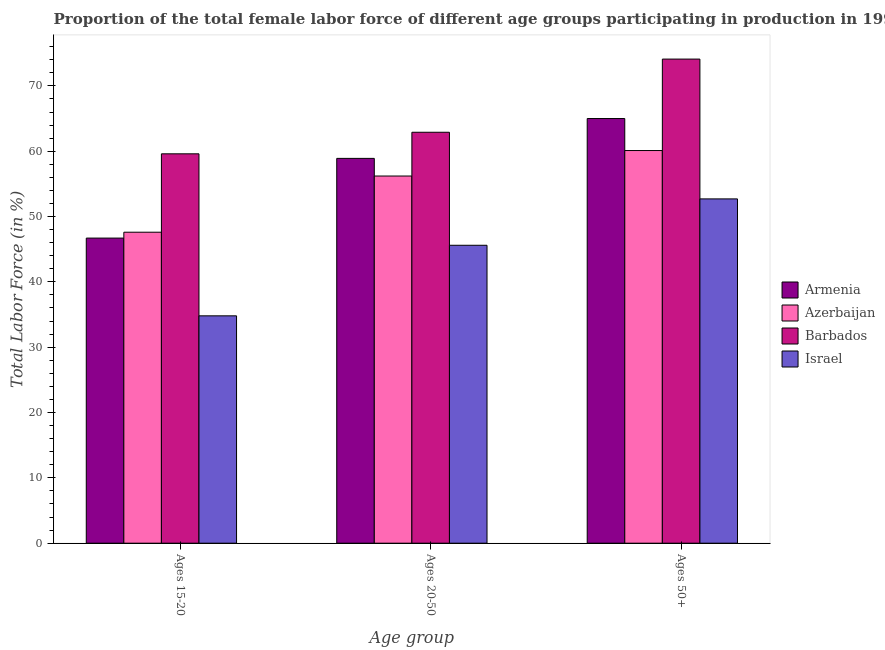Are the number of bars per tick equal to the number of legend labels?
Keep it short and to the point. Yes. Are the number of bars on each tick of the X-axis equal?
Ensure brevity in your answer.  Yes. How many bars are there on the 1st tick from the right?
Give a very brief answer. 4. What is the label of the 1st group of bars from the left?
Offer a very short reply. Ages 15-20. What is the percentage of female labor force within the age group 20-50 in Israel?
Keep it short and to the point. 45.6. Across all countries, what is the maximum percentage of female labor force within the age group 20-50?
Ensure brevity in your answer.  62.9. Across all countries, what is the minimum percentage of female labor force within the age group 20-50?
Offer a very short reply. 45.6. In which country was the percentage of female labor force within the age group 20-50 maximum?
Provide a succinct answer. Barbados. What is the total percentage of female labor force within the age group 15-20 in the graph?
Keep it short and to the point. 188.7. What is the difference between the percentage of female labor force within the age group 15-20 in Barbados and that in Israel?
Give a very brief answer. 24.8. What is the difference between the percentage of female labor force above age 50 in Armenia and the percentage of female labor force within the age group 15-20 in Israel?
Keep it short and to the point. 30.2. What is the average percentage of female labor force above age 50 per country?
Give a very brief answer. 62.97. What is the difference between the percentage of female labor force within the age group 20-50 and percentage of female labor force above age 50 in Azerbaijan?
Your answer should be compact. -3.9. In how many countries, is the percentage of female labor force above age 50 greater than 64 %?
Offer a terse response. 2. What is the ratio of the percentage of female labor force above age 50 in Azerbaijan to that in Armenia?
Your answer should be very brief. 0.92. Is the percentage of female labor force within the age group 20-50 in Azerbaijan less than that in Israel?
Offer a terse response. No. What is the difference between the highest and the lowest percentage of female labor force within the age group 20-50?
Your answer should be compact. 17.3. Is the sum of the percentage of female labor force within the age group 20-50 in Israel and Azerbaijan greater than the maximum percentage of female labor force within the age group 15-20 across all countries?
Offer a terse response. Yes. What does the 3rd bar from the right in Ages 50+ represents?
Offer a terse response. Azerbaijan. How many bars are there?
Offer a very short reply. 12. How many countries are there in the graph?
Offer a very short reply. 4. What is the difference between two consecutive major ticks on the Y-axis?
Your answer should be very brief. 10. Are the values on the major ticks of Y-axis written in scientific E-notation?
Keep it short and to the point. No. Does the graph contain any zero values?
Offer a terse response. No. Does the graph contain grids?
Keep it short and to the point. No. How many legend labels are there?
Keep it short and to the point. 4. How are the legend labels stacked?
Give a very brief answer. Vertical. What is the title of the graph?
Your response must be concise. Proportion of the total female labor force of different age groups participating in production in 1995. What is the label or title of the X-axis?
Your answer should be compact. Age group. What is the Total Labor Force (in %) of Armenia in Ages 15-20?
Give a very brief answer. 46.7. What is the Total Labor Force (in %) in Azerbaijan in Ages 15-20?
Offer a terse response. 47.6. What is the Total Labor Force (in %) of Barbados in Ages 15-20?
Keep it short and to the point. 59.6. What is the Total Labor Force (in %) of Israel in Ages 15-20?
Your answer should be very brief. 34.8. What is the Total Labor Force (in %) in Armenia in Ages 20-50?
Keep it short and to the point. 58.9. What is the Total Labor Force (in %) in Azerbaijan in Ages 20-50?
Provide a succinct answer. 56.2. What is the Total Labor Force (in %) in Barbados in Ages 20-50?
Offer a terse response. 62.9. What is the Total Labor Force (in %) in Israel in Ages 20-50?
Ensure brevity in your answer.  45.6. What is the Total Labor Force (in %) of Azerbaijan in Ages 50+?
Your answer should be very brief. 60.1. What is the Total Labor Force (in %) of Barbados in Ages 50+?
Make the answer very short. 74.1. What is the Total Labor Force (in %) of Israel in Ages 50+?
Provide a succinct answer. 52.7. Across all Age group, what is the maximum Total Labor Force (in %) of Armenia?
Offer a very short reply. 65. Across all Age group, what is the maximum Total Labor Force (in %) of Azerbaijan?
Provide a short and direct response. 60.1. Across all Age group, what is the maximum Total Labor Force (in %) of Barbados?
Your answer should be compact. 74.1. Across all Age group, what is the maximum Total Labor Force (in %) of Israel?
Your answer should be compact. 52.7. Across all Age group, what is the minimum Total Labor Force (in %) of Armenia?
Keep it short and to the point. 46.7. Across all Age group, what is the minimum Total Labor Force (in %) of Azerbaijan?
Your answer should be very brief. 47.6. Across all Age group, what is the minimum Total Labor Force (in %) in Barbados?
Provide a short and direct response. 59.6. Across all Age group, what is the minimum Total Labor Force (in %) in Israel?
Offer a very short reply. 34.8. What is the total Total Labor Force (in %) of Armenia in the graph?
Your response must be concise. 170.6. What is the total Total Labor Force (in %) of Azerbaijan in the graph?
Provide a succinct answer. 163.9. What is the total Total Labor Force (in %) of Barbados in the graph?
Offer a terse response. 196.6. What is the total Total Labor Force (in %) in Israel in the graph?
Provide a short and direct response. 133.1. What is the difference between the Total Labor Force (in %) in Armenia in Ages 15-20 and that in Ages 20-50?
Your answer should be compact. -12.2. What is the difference between the Total Labor Force (in %) of Azerbaijan in Ages 15-20 and that in Ages 20-50?
Give a very brief answer. -8.6. What is the difference between the Total Labor Force (in %) of Barbados in Ages 15-20 and that in Ages 20-50?
Your answer should be compact. -3.3. What is the difference between the Total Labor Force (in %) in Israel in Ages 15-20 and that in Ages 20-50?
Provide a succinct answer. -10.8. What is the difference between the Total Labor Force (in %) in Armenia in Ages 15-20 and that in Ages 50+?
Give a very brief answer. -18.3. What is the difference between the Total Labor Force (in %) of Barbados in Ages 15-20 and that in Ages 50+?
Ensure brevity in your answer.  -14.5. What is the difference between the Total Labor Force (in %) of Israel in Ages 15-20 and that in Ages 50+?
Make the answer very short. -17.9. What is the difference between the Total Labor Force (in %) of Armenia in Ages 20-50 and that in Ages 50+?
Make the answer very short. -6.1. What is the difference between the Total Labor Force (in %) of Israel in Ages 20-50 and that in Ages 50+?
Provide a succinct answer. -7.1. What is the difference between the Total Labor Force (in %) in Armenia in Ages 15-20 and the Total Labor Force (in %) in Azerbaijan in Ages 20-50?
Provide a succinct answer. -9.5. What is the difference between the Total Labor Force (in %) of Armenia in Ages 15-20 and the Total Labor Force (in %) of Barbados in Ages 20-50?
Make the answer very short. -16.2. What is the difference between the Total Labor Force (in %) in Azerbaijan in Ages 15-20 and the Total Labor Force (in %) in Barbados in Ages 20-50?
Keep it short and to the point. -15.3. What is the difference between the Total Labor Force (in %) in Barbados in Ages 15-20 and the Total Labor Force (in %) in Israel in Ages 20-50?
Provide a succinct answer. 14. What is the difference between the Total Labor Force (in %) in Armenia in Ages 15-20 and the Total Labor Force (in %) in Azerbaijan in Ages 50+?
Give a very brief answer. -13.4. What is the difference between the Total Labor Force (in %) of Armenia in Ages 15-20 and the Total Labor Force (in %) of Barbados in Ages 50+?
Give a very brief answer. -27.4. What is the difference between the Total Labor Force (in %) of Azerbaijan in Ages 15-20 and the Total Labor Force (in %) of Barbados in Ages 50+?
Keep it short and to the point. -26.5. What is the difference between the Total Labor Force (in %) of Azerbaijan in Ages 15-20 and the Total Labor Force (in %) of Israel in Ages 50+?
Your answer should be very brief. -5.1. What is the difference between the Total Labor Force (in %) in Armenia in Ages 20-50 and the Total Labor Force (in %) in Barbados in Ages 50+?
Make the answer very short. -15.2. What is the difference between the Total Labor Force (in %) in Armenia in Ages 20-50 and the Total Labor Force (in %) in Israel in Ages 50+?
Your response must be concise. 6.2. What is the difference between the Total Labor Force (in %) of Azerbaijan in Ages 20-50 and the Total Labor Force (in %) of Barbados in Ages 50+?
Give a very brief answer. -17.9. What is the difference between the Total Labor Force (in %) of Azerbaijan in Ages 20-50 and the Total Labor Force (in %) of Israel in Ages 50+?
Provide a short and direct response. 3.5. What is the average Total Labor Force (in %) of Armenia per Age group?
Provide a succinct answer. 56.87. What is the average Total Labor Force (in %) in Azerbaijan per Age group?
Your response must be concise. 54.63. What is the average Total Labor Force (in %) of Barbados per Age group?
Offer a very short reply. 65.53. What is the average Total Labor Force (in %) of Israel per Age group?
Offer a terse response. 44.37. What is the difference between the Total Labor Force (in %) of Armenia and Total Labor Force (in %) of Azerbaijan in Ages 15-20?
Keep it short and to the point. -0.9. What is the difference between the Total Labor Force (in %) of Armenia and Total Labor Force (in %) of Barbados in Ages 15-20?
Your response must be concise. -12.9. What is the difference between the Total Labor Force (in %) in Azerbaijan and Total Labor Force (in %) in Barbados in Ages 15-20?
Your answer should be compact. -12. What is the difference between the Total Labor Force (in %) in Azerbaijan and Total Labor Force (in %) in Israel in Ages 15-20?
Provide a succinct answer. 12.8. What is the difference between the Total Labor Force (in %) in Barbados and Total Labor Force (in %) in Israel in Ages 15-20?
Ensure brevity in your answer.  24.8. What is the difference between the Total Labor Force (in %) of Armenia and Total Labor Force (in %) of Azerbaijan in Ages 20-50?
Provide a succinct answer. 2.7. What is the difference between the Total Labor Force (in %) of Armenia and Total Labor Force (in %) of Barbados in Ages 20-50?
Provide a short and direct response. -4. What is the difference between the Total Labor Force (in %) of Azerbaijan and Total Labor Force (in %) of Barbados in Ages 20-50?
Your answer should be compact. -6.7. What is the difference between the Total Labor Force (in %) in Barbados and Total Labor Force (in %) in Israel in Ages 20-50?
Offer a very short reply. 17.3. What is the difference between the Total Labor Force (in %) in Armenia and Total Labor Force (in %) in Israel in Ages 50+?
Your answer should be very brief. 12.3. What is the difference between the Total Labor Force (in %) in Barbados and Total Labor Force (in %) in Israel in Ages 50+?
Provide a short and direct response. 21.4. What is the ratio of the Total Labor Force (in %) in Armenia in Ages 15-20 to that in Ages 20-50?
Your answer should be very brief. 0.79. What is the ratio of the Total Labor Force (in %) in Azerbaijan in Ages 15-20 to that in Ages 20-50?
Provide a short and direct response. 0.85. What is the ratio of the Total Labor Force (in %) of Barbados in Ages 15-20 to that in Ages 20-50?
Provide a succinct answer. 0.95. What is the ratio of the Total Labor Force (in %) of Israel in Ages 15-20 to that in Ages 20-50?
Provide a short and direct response. 0.76. What is the ratio of the Total Labor Force (in %) in Armenia in Ages 15-20 to that in Ages 50+?
Your answer should be very brief. 0.72. What is the ratio of the Total Labor Force (in %) in Azerbaijan in Ages 15-20 to that in Ages 50+?
Your answer should be very brief. 0.79. What is the ratio of the Total Labor Force (in %) in Barbados in Ages 15-20 to that in Ages 50+?
Make the answer very short. 0.8. What is the ratio of the Total Labor Force (in %) in Israel in Ages 15-20 to that in Ages 50+?
Ensure brevity in your answer.  0.66. What is the ratio of the Total Labor Force (in %) in Armenia in Ages 20-50 to that in Ages 50+?
Keep it short and to the point. 0.91. What is the ratio of the Total Labor Force (in %) in Azerbaijan in Ages 20-50 to that in Ages 50+?
Provide a succinct answer. 0.94. What is the ratio of the Total Labor Force (in %) of Barbados in Ages 20-50 to that in Ages 50+?
Make the answer very short. 0.85. What is the ratio of the Total Labor Force (in %) of Israel in Ages 20-50 to that in Ages 50+?
Your answer should be compact. 0.87. What is the difference between the highest and the second highest Total Labor Force (in %) in Armenia?
Your answer should be very brief. 6.1. What is the difference between the highest and the lowest Total Labor Force (in %) of Armenia?
Ensure brevity in your answer.  18.3. What is the difference between the highest and the lowest Total Labor Force (in %) of Barbados?
Your answer should be compact. 14.5. 